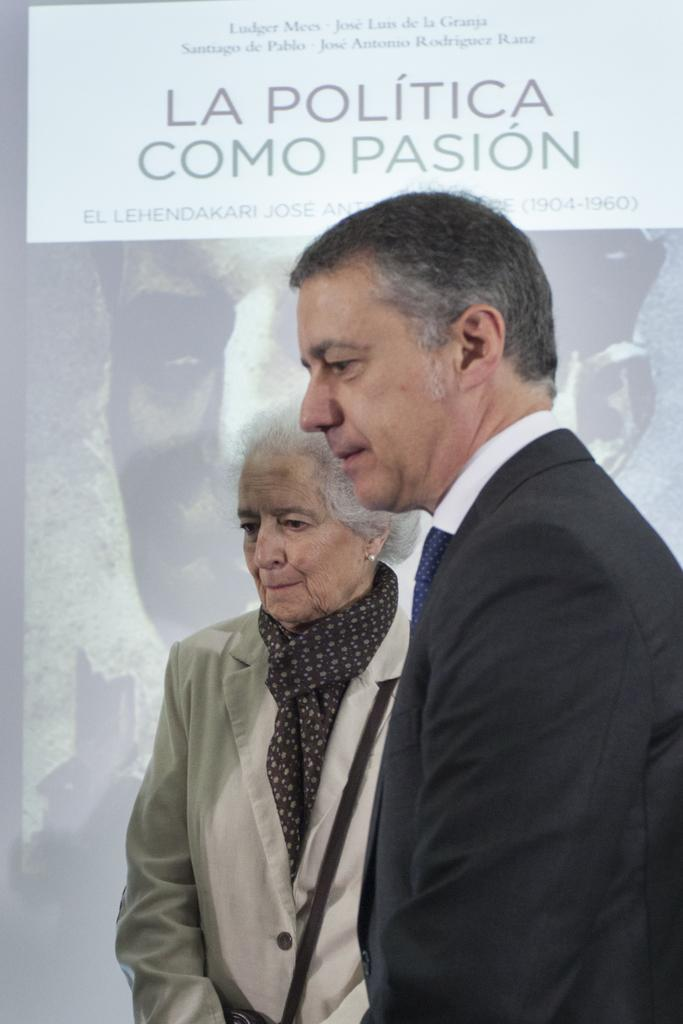How many people are in the image? There are two persons standing in the center of the image. What can be seen in the background of the image? There is a banner in the background of the image. What is depicted on the banner? There is a person depicted on the banner. What else is present on the banner besides the person? There is text on the banner. Reasoning: Let' Let's think step by step in order to produce the conversation. We start by identifying the main subjects in the image, which are the two persons standing in the center. Then, we describe the background of the image, which features a banner. We then expand the conversation to include details about the banner, such as the person depicted on it and the presence of text. Absurd Question/Answer: What type of birds can be seen sitting on the sofa in the image? There are no birds or sofas present in the image. 